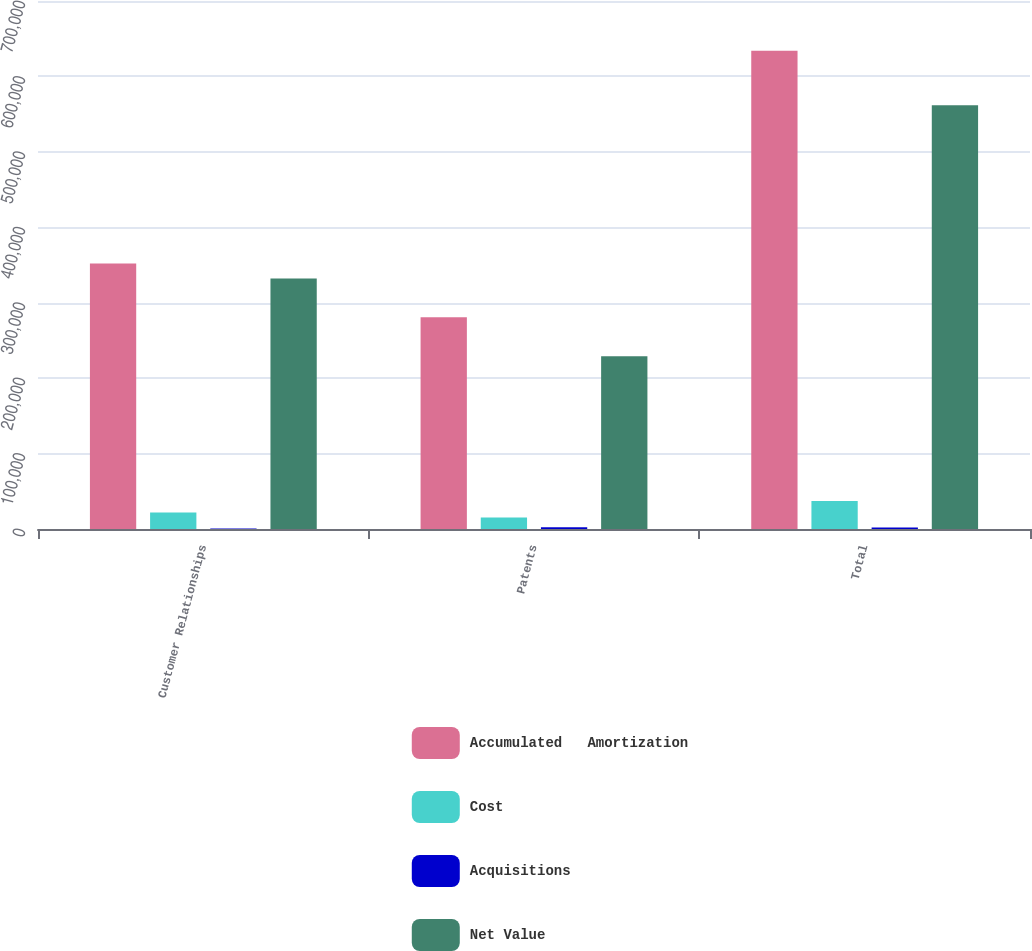Convert chart. <chart><loc_0><loc_0><loc_500><loc_500><stacked_bar_chart><ecel><fcel>Customer Relationships<fcel>Patents<fcel>Total<nl><fcel>Accumulated   Amortization<fcel>351873<fcel>280623<fcel>633985<nl><fcel>Cost<fcel>21792<fcel>15188<fcel>36980<nl><fcel>Acquisitions<fcel>548<fcel>2188<fcel>1984<nl><fcel>Net Value<fcel>332119<fcel>228928<fcel>561939<nl></chart> 